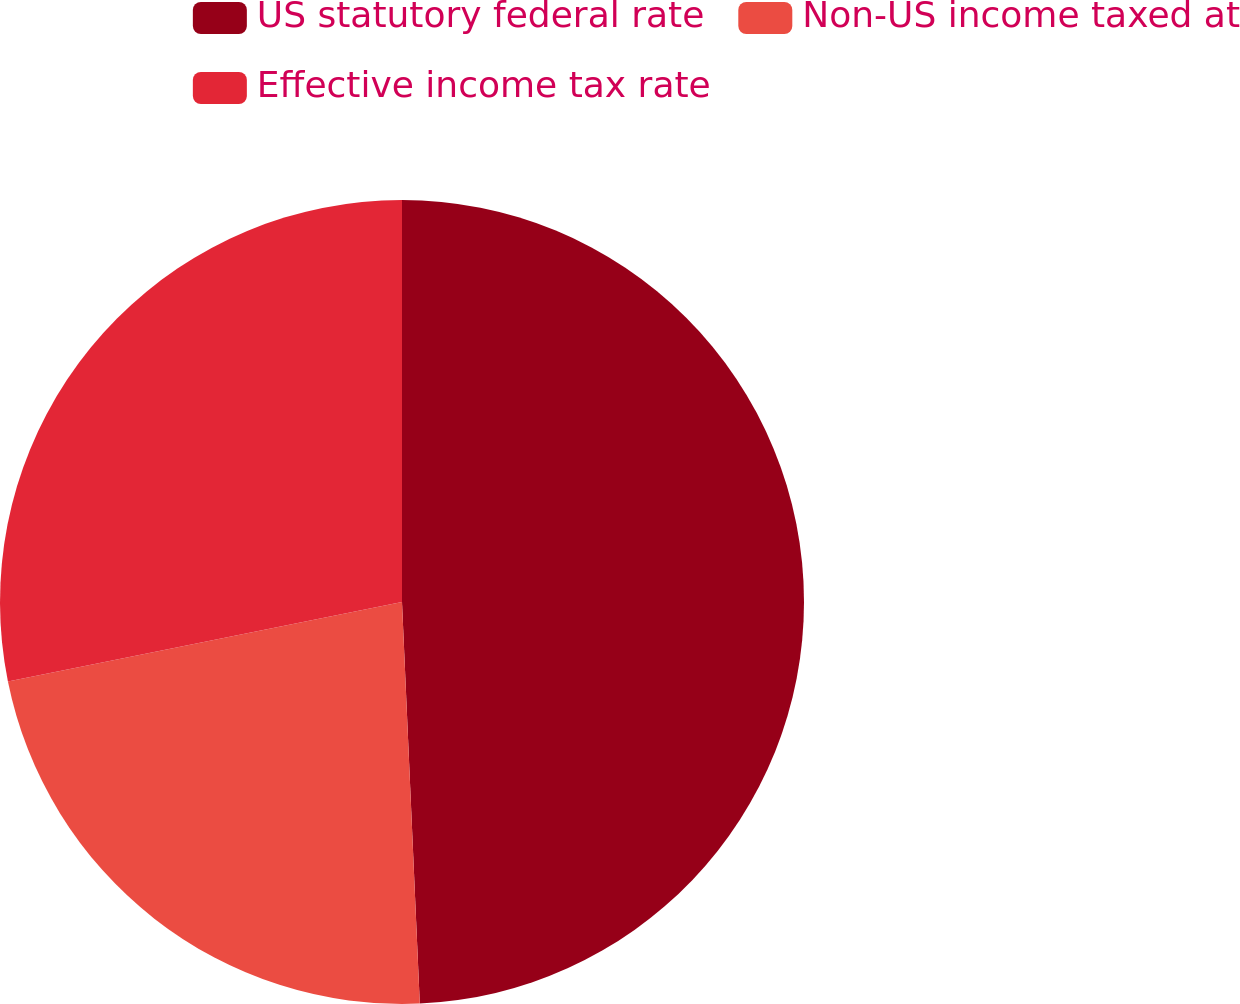Convert chart. <chart><loc_0><loc_0><loc_500><loc_500><pie_chart><fcel>US statutory federal rate<fcel>Non-US income taxed at<fcel>Effective income tax rate<nl><fcel>49.3%<fcel>22.54%<fcel>28.17%<nl></chart> 